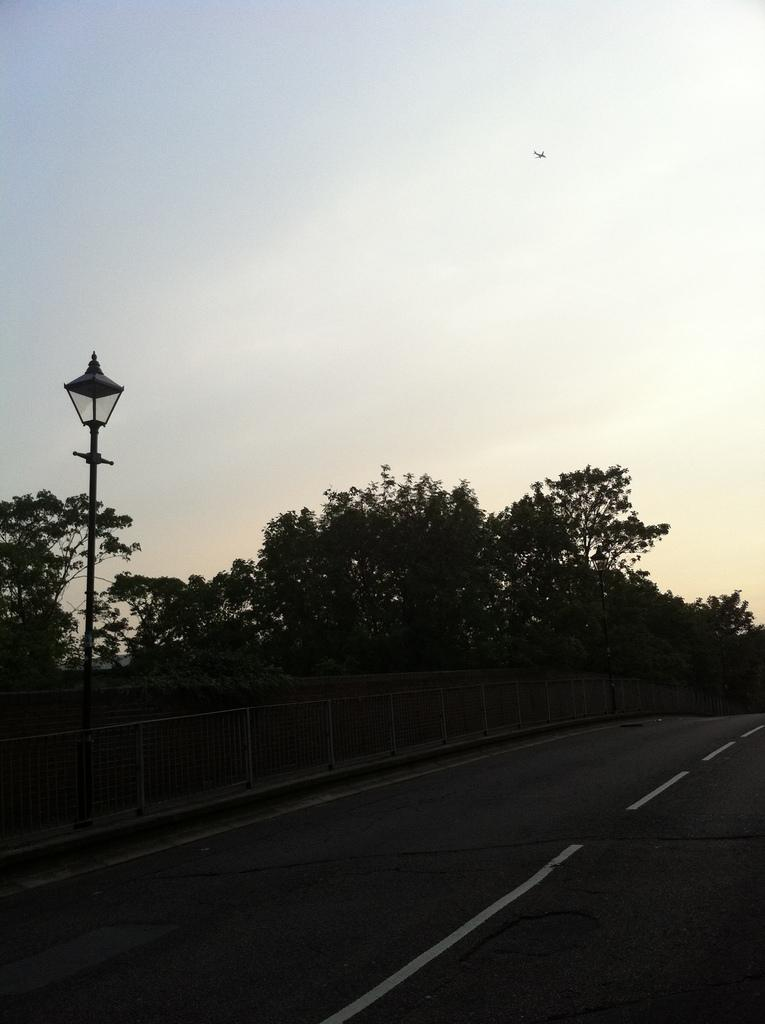What is the main feature of the image? There is a road in the image. What type of vegetation can be seen in the image? There are plants and trees in the image. Can you describe any man-made structures in the image? There is a pole with a lamp in the image. What kind of pleasure can be seen enjoying the things in the image? There is no person or pleasure present in the image; it only features a road, plants, trees, and a pole with a lamp. 